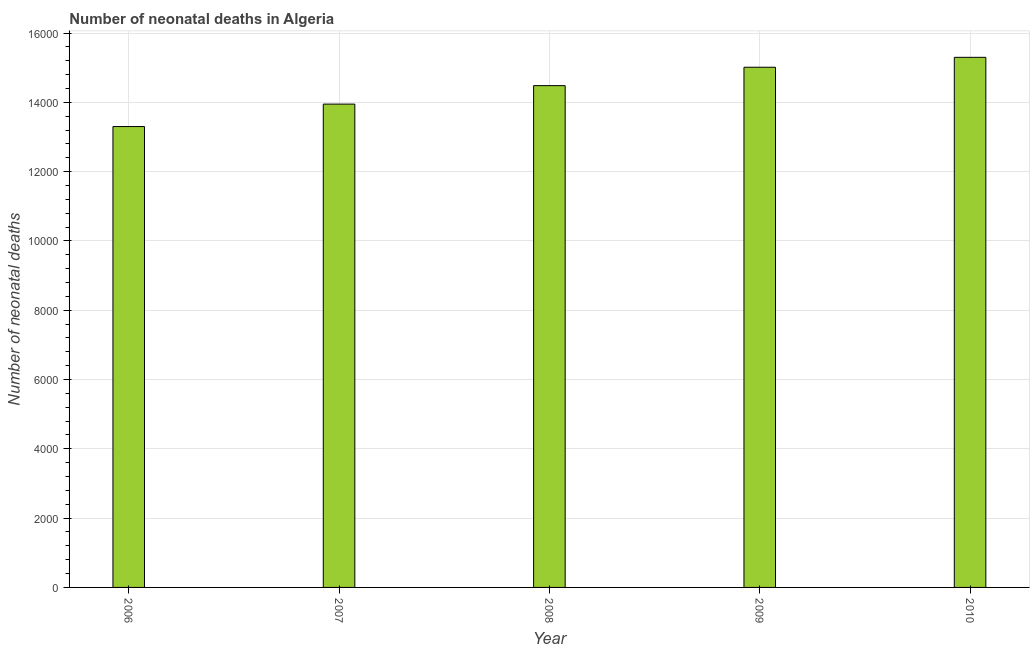Does the graph contain any zero values?
Provide a succinct answer. No. Does the graph contain grids?
Provide a short and direct response. Yes. What is the title of the graph?
Provide a short and direct response. Number of neonatal deaths in Algeria. What is the label or title of the Y-axis?
Keep it short and to the point. Number of neonatal deaths. What is the number of neonatal deaths in 2010?
Keep it short and to the point. 1.53e+04. Across all years, what is the maximum number of neonatal deaths?
Offer a very short reply. 1.53e+04. Across all years, what is the minimum number of neonatal deaths?
Give a very brief answer. 1.33e+04. In which year was the number of neonatal deaths minimum?
Ensure brevity in your answer.  2006. What is the sum of the number of neonatal deaths?
Offer a terse response. 7.20e+04. What is the difference between the number of neonatal deaths in 2008 and 2009?
Ensure brevity in your answer.  -531. What is the average number of neonatal deaths per year?
Offer a terse response. 1.44e+04. What is the median number of neonatal deaths?
Make the answer very short. 1.45e+04. What is the ratio of the number of neonatal deaths in 2006 to that in 2007?
Provide a succinct answer. 0.95. Is the number of neonatal deaths in 2007 less than that in 2009?
Offer a terse response. Yes. What is the difference between the highest and the second highest number of neonatal deaths?
Offer a very short reply. 286. What is the difference between the highest and the lowest number of neonatal deaths?
Provide a succinct answer. 1998. In how many years, is the number of neonatal deaths greater than the average number of neonatal deaths taken over all years?
Provide a succinct answer. 3. How many bars are there?
Give a very brief answer. 5. Are all the bars in the graph horizontal?
Your response must be concise. No. What is the difference between two consecutive major ticks on the Y-axis?
Provide a succinct answer. 2000. Are the values on the major ticks of Y-axis written in scientific E-notation?
Make the answer very short. No. What is the Number of neonatal deaths of 2006?
Your answer should be compact. 1.33e+04. What is the Number of neonatal deaths in 2007?
Your response must be concise. 1.39e+04. What is the Number of neonatal deaths in 2008?
Give a very brief answer. 1.45e+04. What is the Number of neonatal deaths in 2009?
Provide a succinct answer. 1.50e+04. What is the Number of neonatal deaths in 2010?
Provide a short and direct response. 1.53e+04. What is the difference between the Number of neonatal deaths in 2006 and 2007?
Your response must be concise. -648. What is the difference between the Number of neonatal deaths in 2006 and 2008?
Offer a terse response. -1181. What is the difference between the Number of neonatal deaths in 2006 and 2009?
Provide a short and direct response. -1712. What is the difference between the Number of neonatal deaths in 2006 and 2010?
Give a very brief answer. -1998. What is the difference between the Number of neonatal deaths in 2007 and 2008?
Provide a succinct answer. -533. What is the difference between the Number of neonatal deaths in 2007 and 2009?
Make the answer very short. -1064. What is the difference between the Number of neonatal deaths in 2007 and 2010?
Offer a very short reply. -1350. What is the difference between the Number of neonatal deaths in 2008 and 2009?
Provide a short and direct response. -531. What is the difference between the Number of neonatal deaths in 2008 and 2010?
Keep it short and to the point. -817. What is the difference between the Number of neonatal deaths in 2009 and 2010?
Provide a short and direct response. -286. What is the ratio of the Number of neonatal deaths in 2006 to that in 2007?
Your response must be concise. 0.95. What is the ratio of the Number of neonatal deaths in 2006 to that in 2008?
Make the answer very short. 0.92. What is the ratio of the Number of neonatal deaths in 2006 to that in 2009?
Offer a very short reply. 0.89. What is the ratio of the Number of neonatal deaths in 2006 to that in 2010?
Provide a succinct answer. 0.87. What is the ratio of the Number of neonatal deaths in 2007 to that in 2009?
Your answer should be compact. 0.93. What is the ratio of the Number of neonatal deaths in 2007 to that in 2010?
Ensure brevity in your answer.  0.91. What is the ratio of the Number of neonatal deaths in 2008 to that in 2009?
Provide a succinct answer. 0.96. What is the ratio of the Number of neonatal deaths in 2008 to that in 2010?
Offer a terse response. 0.95. What is the ratio of the Number of neonatal deaths in 2009 to that in 2010?
Make the answer very short. 0.98. 